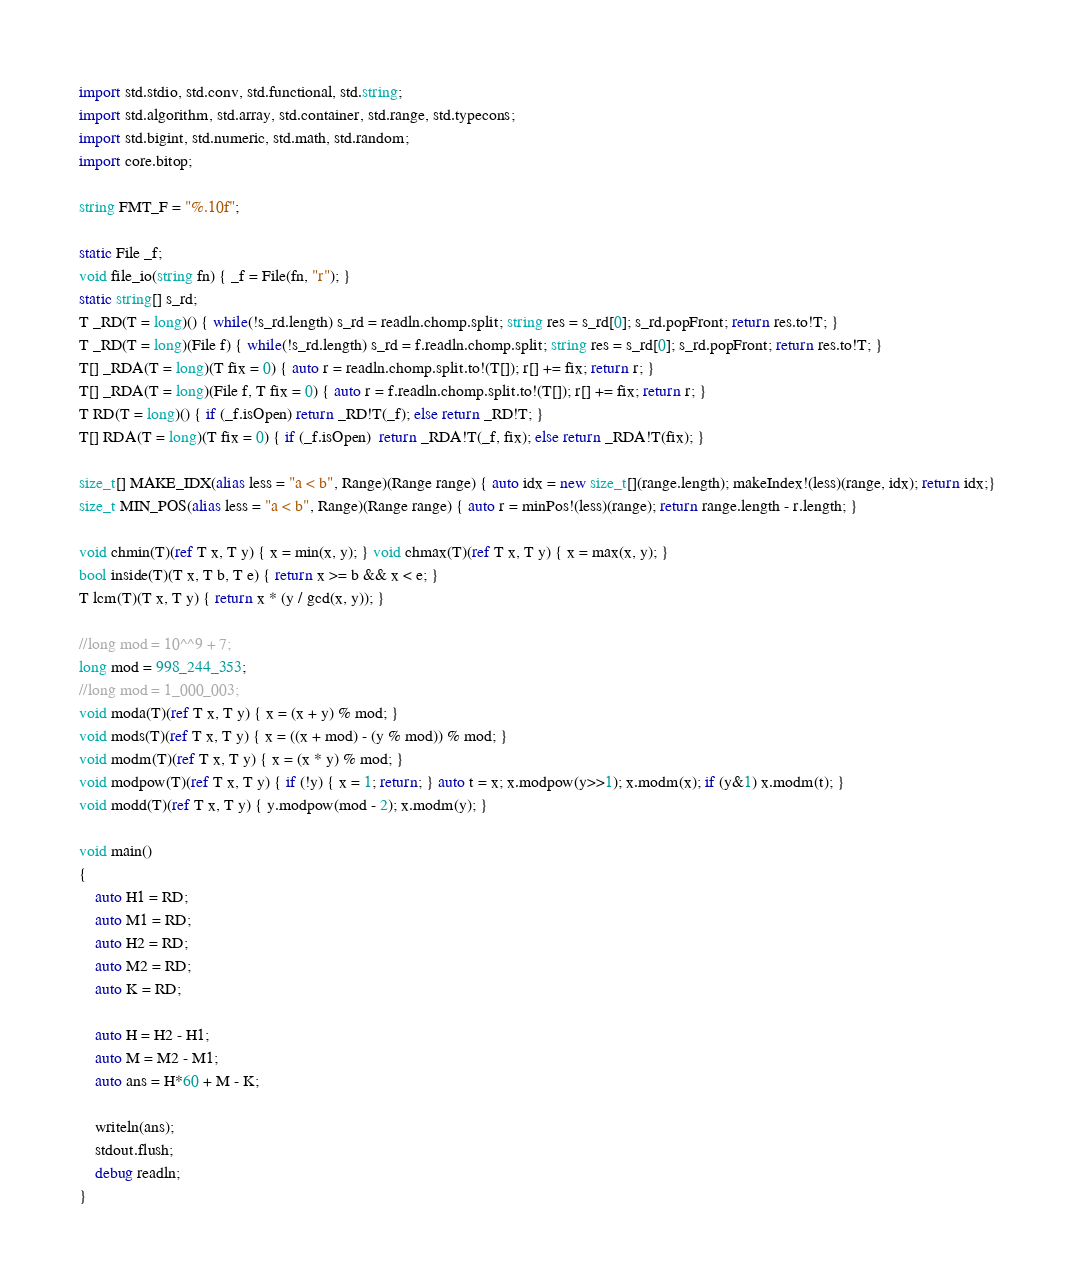<code> <loc_0><loc_0><loc_500><loc_500><_D_>import std.stdio, std.conv, std.functional, std.string;
import std.algorithm, std.array, std.container, std.range, std.typecons;
import std.bigint, std.numeric, std.math, std.random;
import core.bitop;

string FMT_F = "%.10f";

static File _f;
void file_io(string fn) { _f = File(fn, "r"); }
static string[] s_rd;
T _RD(T = long)() { while(!s_rd.length) s_rd = readln.chomp.split; string res = s_rd[0]; s_rd.popFront; return res.to!T; }
T _RD(T = long)(File f) { while(!s_rd.length) s_rd = f.readln.chomp.split; string res = s_rd[0]; s_rd.popFront; return res.to!T; }
T[] _RDA(T = long)(T fix = 0) { auto r = readln.chomp.split.to!(T[]); r[] += fix; return r; }
T[] _RDA(T = long)(File f, T fix = 0) { auto r = f.readln.chomp.split.to!(T[]); r[] += fix; return r; }
T RD(T = long)() { if (_f.isOpen) return _RD!T(_f); else return _RD!T; }
T[] RDA(T = long)(T fix = 0) { if (_f.isOpen)  return _RDA!T(_f, fix); else return _RDA!T(fix); }

size_t[] MAKE_IDX(alias less = "a < b", Range)(Range range) { auto idx = new size_t[](range.length); makeIndex!(less)(range, idx); return idx;}
size_t MIN_POS(alias less = "a < b", Range)(Range range) { auto r = minPos!(less)(range); return range.length - r.length; }

void chmin(T)(ref T x, T y) { x = min(x, y); } void chmax(T)(ref T x, T y) { x = max(x, y); }
bool inside(T)(T x, T b, T e) { return x >= b && x < e; }
T lcm(T)(T x, T y) { return x * (y / gcd(x, y)); }

//long mod = 10^^9 + 7;
long mod = 998_244_353;
//long mod = 1_000_003;
void moda(T)(ref T x, T y) { x = (x + y) % mod; }
void mods(T)(ref T x, T y) { x = ((x + mod) - (y % mod)) % mod; }
void modm(T)(ref T x, T y) { x = (x * y) % mod; }
void modpow(T)(ref T x, T y) { if (!y) { x = 1; return; } auto t = x; x.modpow(y>>1); x.modm(x); if (y&1) x.modm(t); }
void modd(T)(ref T x, T y) { y.modpow(mod - 2); x.modm(y); }

void main()
{
	auto H1 = RD;
	auto M1 = RD;
	auto H2 = RD;
	auto M2 = RD;
	auto K = RD;

	auto H = H2 - H1;
	auto M = M2 - M1;
	auto ans = H*60 + M - K;

	writeln(ans);
	stdout.flush;
	debug readln;
}</code> 